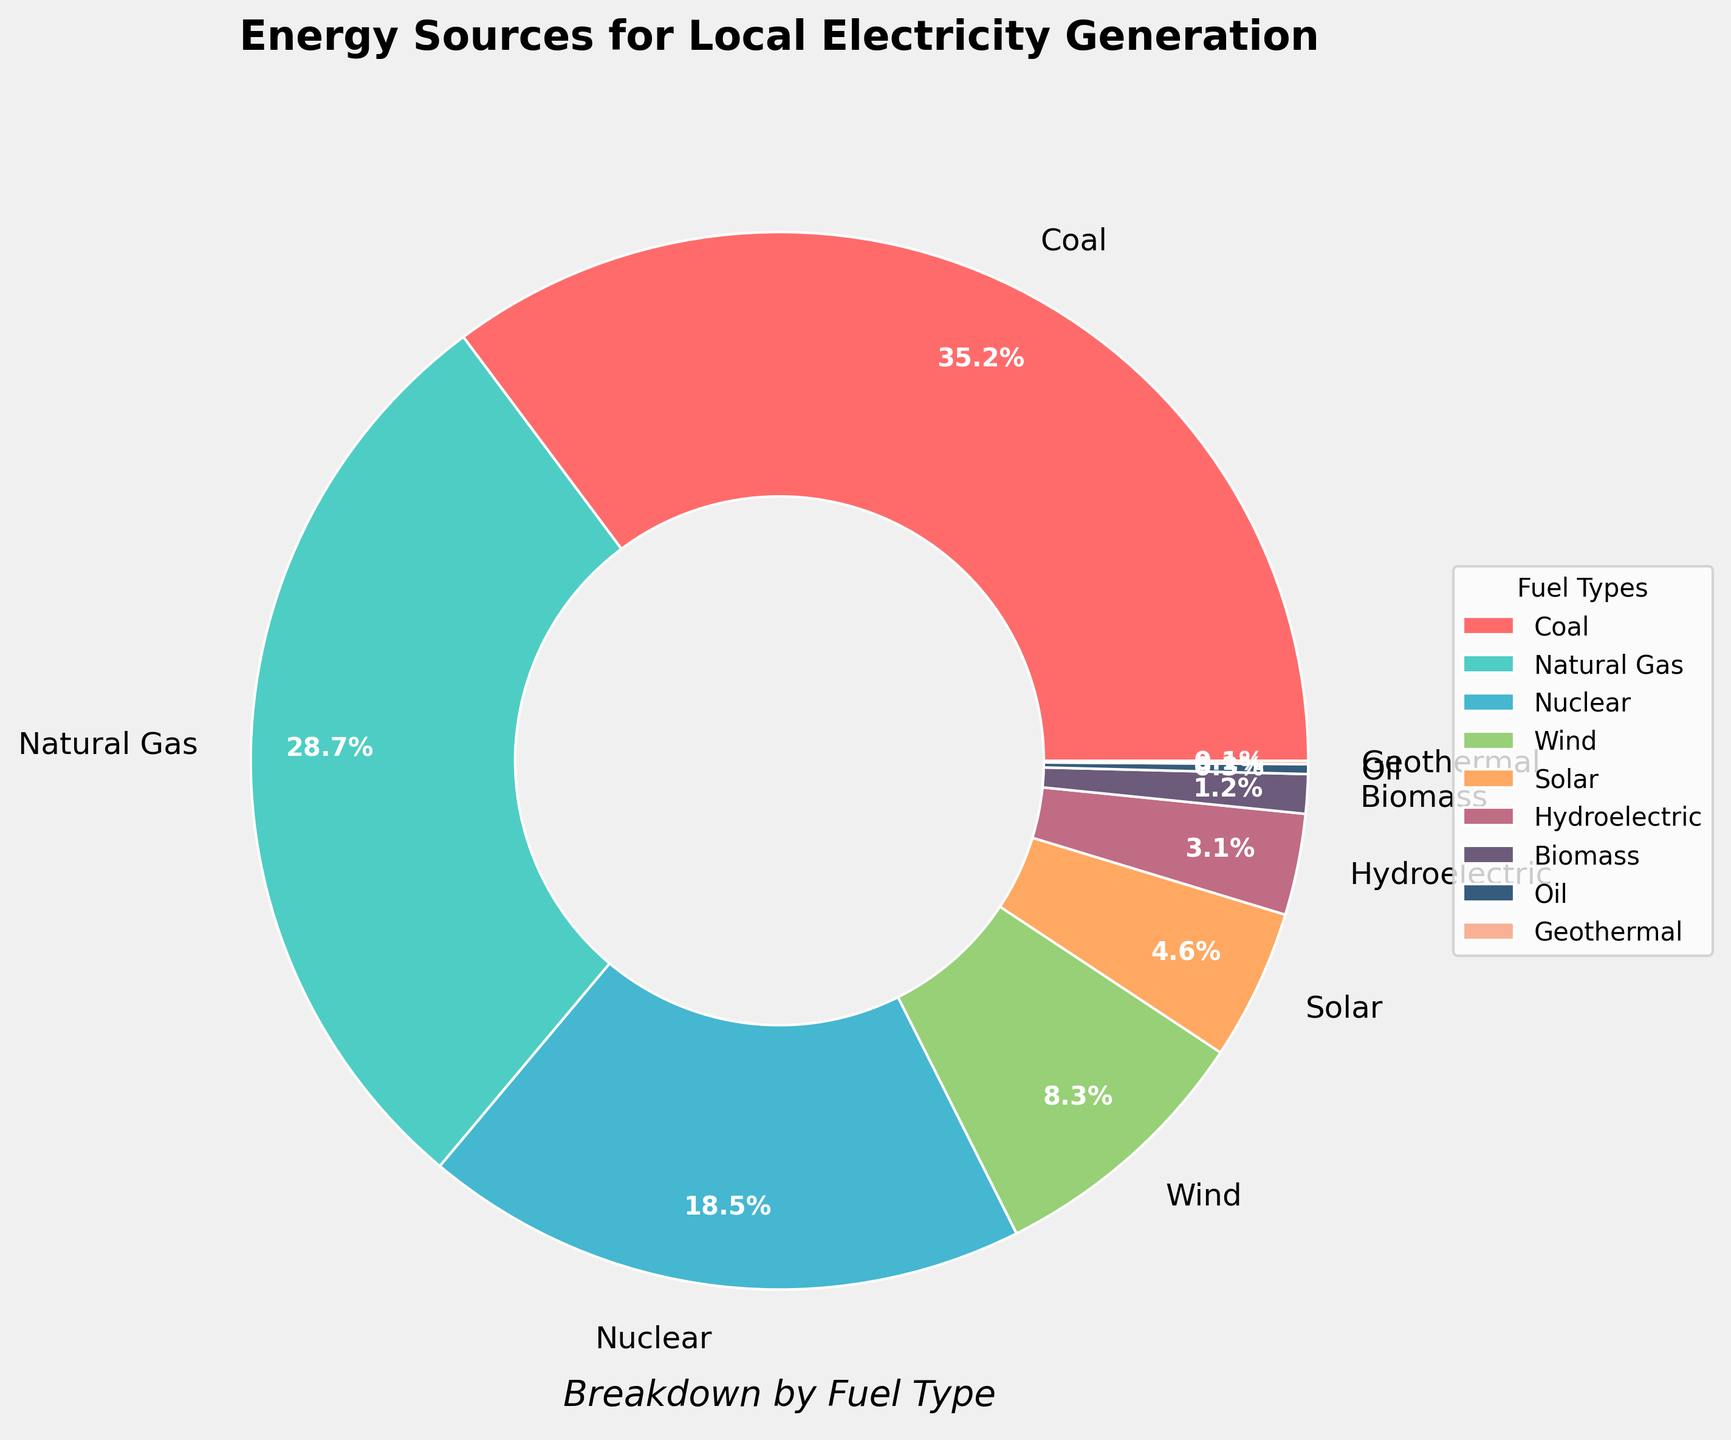Which fuel type has the highest percentage in local electricity generation? The largest wedge is labeled "Coal" with a percentage of 35.2% according to the chart.
Answer: Coal What is the total percentage of renewable energy sources (Wind, Solar, Hydroelectric, Biomass, and Geothermal)? Add the percentages of Wind (8.3%), Solar (4.6%), Hydroelectric (3.1%), Biomass (1.2%), and Geothermal (0.1%). The total is 8.3 + 4.6 + 3.1 + 1.2 + 0.1 = 17.3%.
Answer: 17.3% Which has a lower percentage, Nuclear or Natural Gas, and by how much? Natural Gas has a percentage of 28.7%, and Nuclear has 18.5%. Subtract Nuclear's percentage from Natural Gas's: 28.7% - 18.5% = 10.2%.
Answer: Nuclear by 10.2% If you combine the percentages of Coal and Natural Gas, what is their combined share of local electricity generation? Add Coal's 35.2% and Natural Gas's 28.7%. The combined share is 35.2% + 28.7% = 63.9%.
Answer: 63.9% What is the third most significant fuel type for local electricity generation in terms of percentage? The third largest wedge after Coal (35.2%) and Natural Gas (28.7%) is labeled Nuclear at 18.5%.
Answer: Nuclear What is the combined percentage of all non-renewable energy sources? Add the percentages of Coal (35.2%), Natural Gas (28.7%), Nuclear (18.5%), and Oil (0.3%). The total is 35.2 + 28.7 + 18.5 + 0.3 = 82.7%.
Answer: 82.7% Is the percentage for Wind energy greater than that for Hydroelectric energy? Yes, the chart shows Wind at 8.3% and Hydroelectric at 3.1%, and 8.3% is greater than 3.1%.
Answer: Yes Which renewable energy source contributes the least, and what is its percentage? The smallest wedge among renewable sources is labeled Geothermal with a percentage of 0.1%.
Answer: Geothermal, 0.1% How much more significant in percentage is Solar energy compared to Biomass? Solar energy is 4.6% and Biomass is 1.2%. Subtract Biomass's percentage from Solar's: 4.6% - 1.2% = 3.4%.
Answer: Solar by 3.4% 